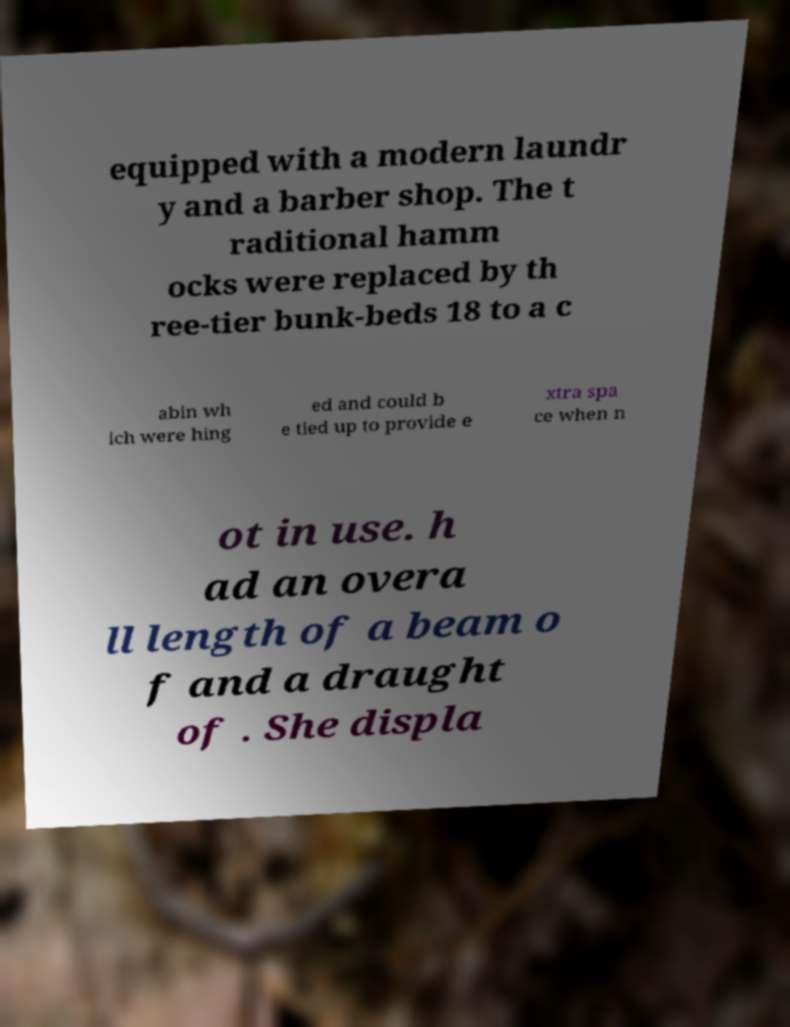Could you assist in decoding the text presented in this image and type it out clearly? equipped with a modern laundr y and a barber shop. The t raditional hamm ocks were replaced by th ree-tier bunk-beds 18 to a c abin wh ich were hing ed and could b e tied up to provide e xtra spa ce when n ot in use. h ad an overa ll length of a beam o f and a draught of . She displa 